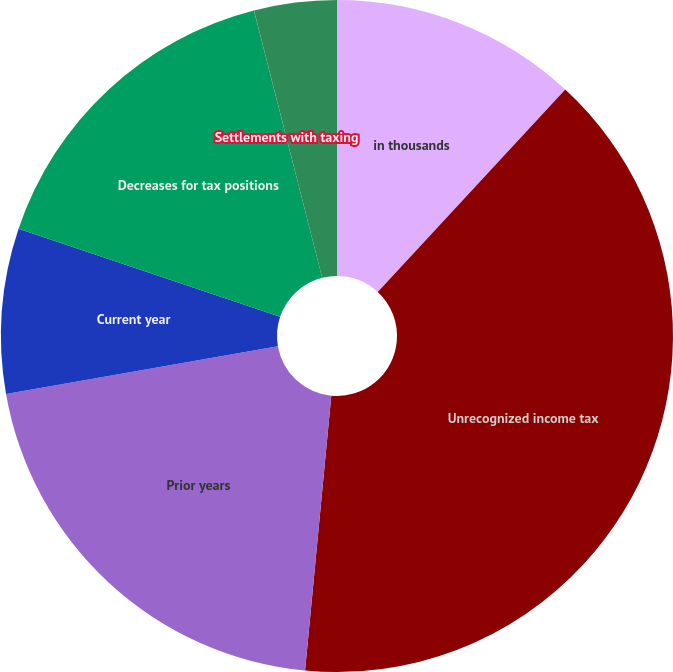Convert chart to OTSL. <chart><loc_0><loc_0><loc_500><loc_500><pie_chart><fcel>in thousands<fcel>Unrecognized income tax<fcel>Prior years<fcel>Current year<fcel>Decreases for tax positions<fcel>Settlements with taxing<fcel>Expiration of applicable<nl><fcel>11.89%<fcel>39.63%<fcel>20.73%<fcel>7.93%<fcel>15.85%<fcel>0.01%<fcel>3.97%<nl></chart> 